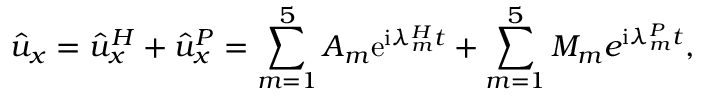Convert formula to latex. <formula><loc_0><loc_0><loc_500><loc_500>\hat { u } _ { x } = \hat { u } _ { x } ^ { H } + \hat { u } _ { x } ^ { P } = \sum _ { m = 1 } ^ { 5 } A _ { m } e ^ { i \lambda _ { m } ^ { H } t } + \sum _ { m = 1 } ^ { 5 } M _ { m } e ^ { i \lambda _ { m } ^ { P } t } ,</formula> 